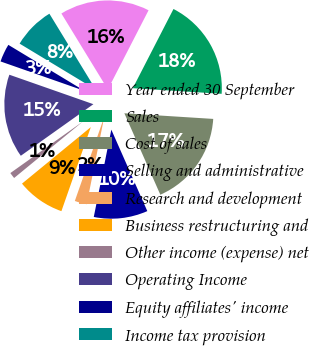Convert chart to OTSL. <chart><loc_0><loc_0><loc_500><loc_500><pie_chart><fcel>Year ended 30 September<fcel>Sales<fcel>Cost of sales<fcel>Selling and administrative<fcel>Research and development<fcel>Business restructuring and<fcel>Other income (expense) net<fcel>Operating Income<fcel>Equity affiliates' income<fcel>Income tax provision<nl><fcel>16.29%<fcel>18.45%<fcel>17.37%<fcel>9.78%<fcel>2.2%<fcel>8.7%<fcel>1.11%<fcel>15.2%<fcel>3.28%<fcel>7.62%<nl></chart> 